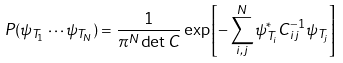<formula> <loc_0><loc_0><loc_500><loc_500>P ( \psi _ { T _ { 1 } } \cdots \psi _ { T _ { N } } ) = \frac { 1 } { \pi ^ { N } \det C } \exp \left [ - \sum _ { i , j } ^ { N } \psi _ { T _ { i } } ^ { * } C _ { i j } ^ { - 1 } \psi _ { T _ { j } } \right ]</formula> 